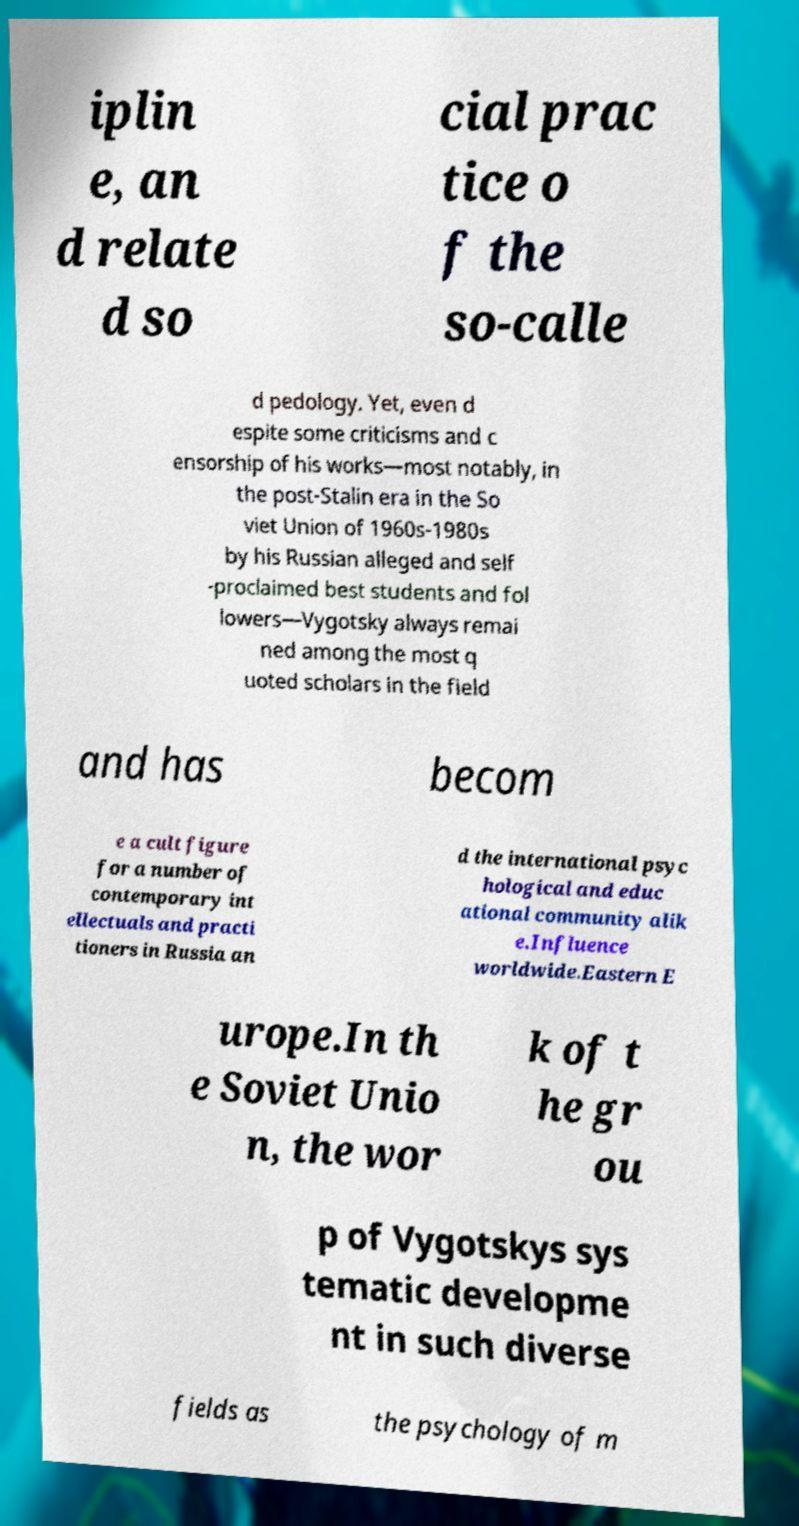Please identify and transcribe the text found in this image. iplin e, an d relate d so cial prac tice o f the so-calle d pedology. Yet, even d espite some criticisms and c ensorship of his works—most notably, in the post-Stalin era in the So viet Union of 1960s-1980s by his Russian alleged and self -proclaimed best students and fol lowers—Vygotsky always remai ned among the most q uoted scholars in the field and has becom e a cult figure for a number of contemporary int ellectuals and practi tioners in Russia an d the international psyc hological and educ ational community alik e.Influence worldwide.Eastern E urope.In th e Soviet Unio n, the wor k of t he gr ou p of Vygotskys sys tematic developme nt in such diverse fields as the psychology of m 